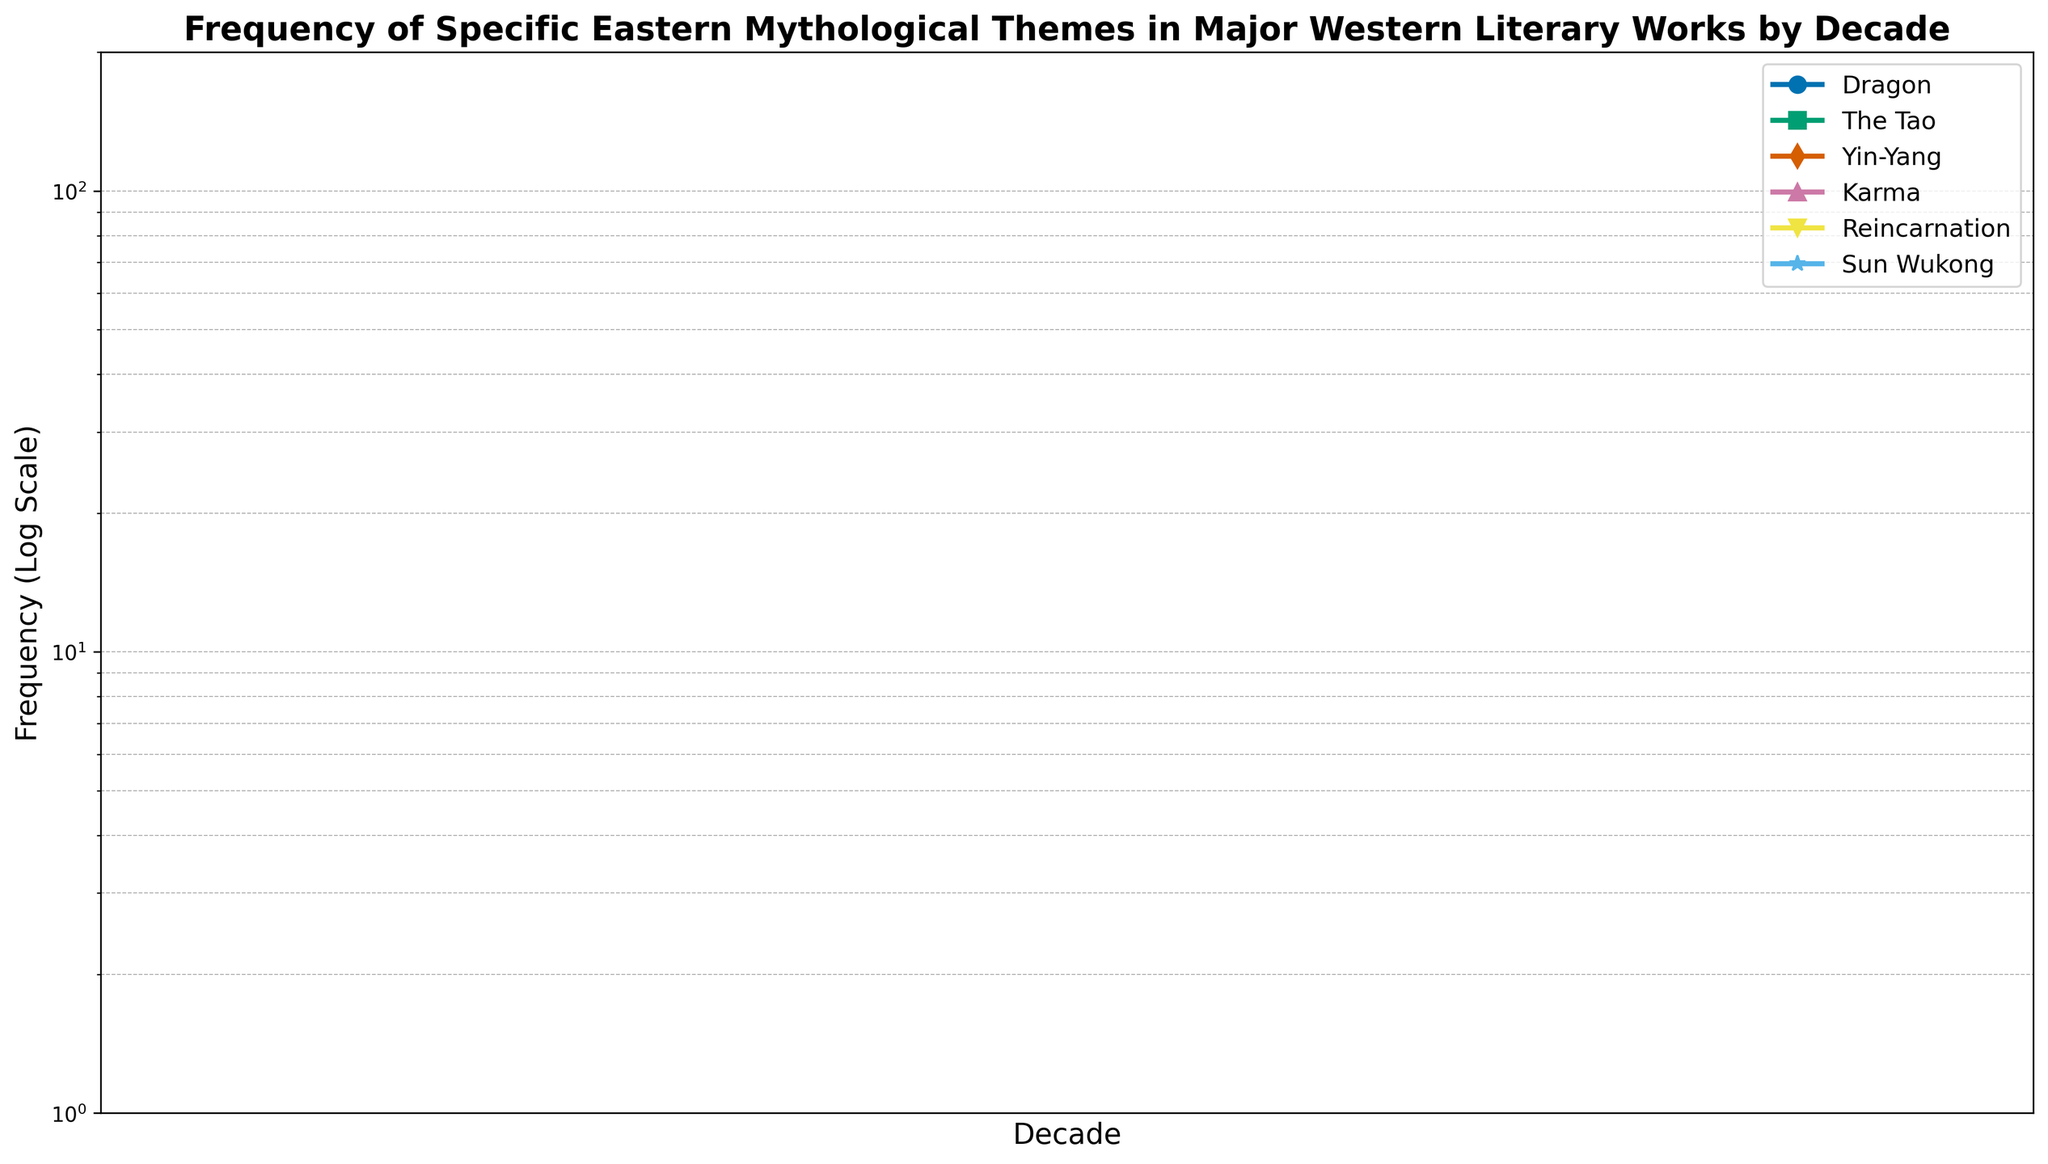Which theme shows the highest frequency in the 2020s? To determine the theme with the highest frequency in the 2020s, we compare the values for all themes in that decade. The highest value is 150 for Reincarnation.
Answer: Reincarnation How many times more frequent is Sun Wukong in the 2020s compared to the 1950s? In the 1950s, the frequency of Sun Wukong is 2. In the 2020s, it is 20. The ratio is 20 divided by 2, which is 10.
Answer: 10 times What is the total frequency of the theme 'Dragon' over the entire timeline? To get the total frequency, add the values of the theme 'Dragon' from each decade: 1 + 2 + 3 + 5 + 4 + 3 + 4 + 8 + 15 + 25 + 50 + 80 + 100 = 300.
Answer: 300 Which decade saw the first appearance of 'Yin-Yang' in Western literature? The first appearance of 'Yin-Yang' is marked by its first non-zero frequency value. Checking the data, 'Yin-Yang' first appears in the 1920s.
Answer: 1920s Which two themes have the least overall growth between the 1900s and the 2020s? To determine the least growth, compare the differences in frequencies between the 1900s and the 2020s for each theme. 'The Tao' grows from 0 to 75, and 'Sun Wukong' grows from 0 to 20. These two have the least growth.
Answer: 'The Tao' and 'Sun Wukong' What is the average frequency of 'Karma' over all the decades? To find the average frequency of 'Karma,' sum its values across all decades and divide by the number of decades. Sum: 0 + 0 + 0 + 1 + 2 + 3 + 7 + 15 + 30 + 55 + 80 + 100 + 130 = 423. There are 13 decades. Average: 423 / 13 ≈ 32.54.
Answer: 32.54 In which decade did the occurrence of 'Reincarnation' surpass the frequency of 'Dragon'? Compare the frequency values of 'Reincarnation' and 'Dragon' across the decades. In the 1960s, 'Reincarnation' (10) surpasses 'Dragon' (4).
Answer: 1960s Is the frequency of 'Yin-Yang' greater or less than 'Dragon' in the 1980s? Comparing the values, 'Yin-Yang' has 20 and 'Dragon' has 15 in the 1980s. 'Yin-Yang' is greater than 'Dragon'.
Answer: Greater What is the difference in the frequency of 'The Tao' between the 1950s and the 1940s? Subtract the frequency of 'The Tao' in the 1940s from its frequency in the 1950s: 3 - 2 = 1.
Answer: 1 Which theme shows the most significant growth from the 1970s to the 2000s? Calculate the difference in frequencies between the 1970s and the 2000s for each theme. 'Reincarnation' grows from 25 to 90, a growth of 65, which is the most significant.
Answer: Reincarnation 